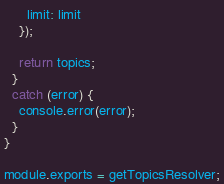Convert code to text. <code><loc_0><loc_0><loc_500><loc_500><_JavaScript_>      limit: limit
    });

    return topics;
  }
  catch (error) {
    console.error(error);
  }
}

module.exports = getTopicsResolver;</code> 